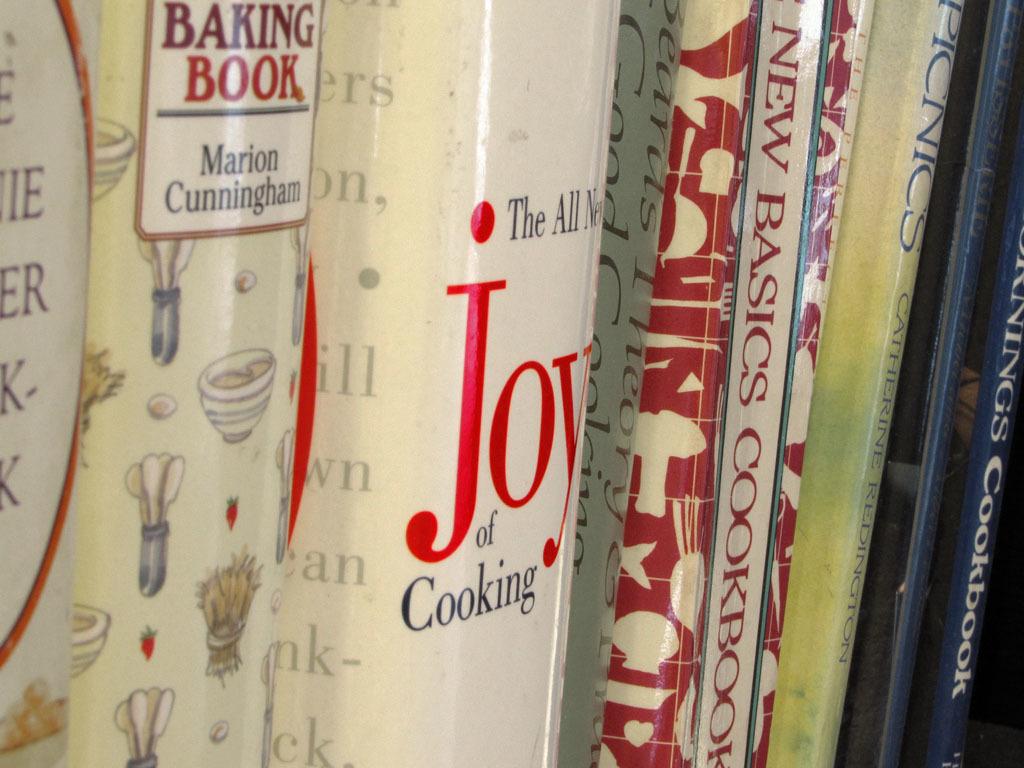What is the book title?
Your answer should be compact. Joy of cooking. 